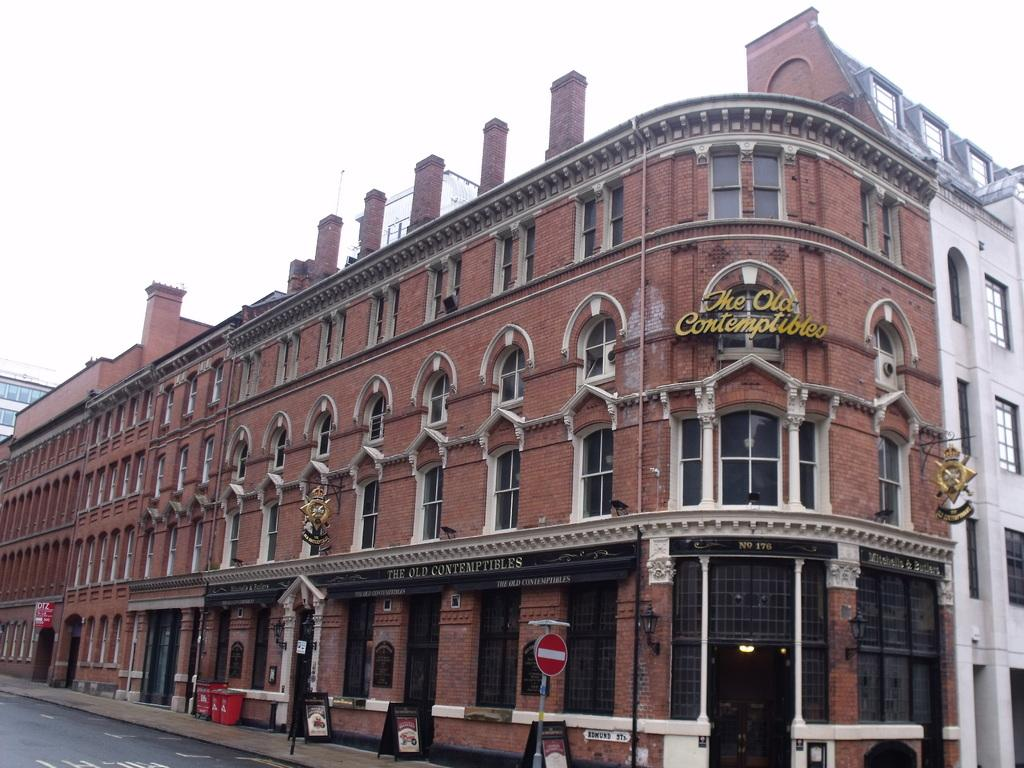What type of structures can be seen in the image? There are buildings in the image. What objects are present in the image that might be used for displaying information? There are boards in the image. What can be seen in the image that might provide illumination? There are lights in the image. What objects are present in the image that might be used for waste disposal? There are bins in the image. What is visible at the top of the image? The sky is visible at the top of the image. What is visible at the bottom of the image? There is a road at the bottom of the image. What type of insurance policy is being advertised on the boards in the image? There is no information about insurance policies on the boards in the image. What hobbies are the people in the image engaged in? There are no people present in the image, so their hobbies cannot be determined. 